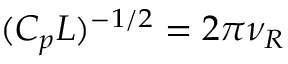<formula> <loc_0><loc_0><loc_500><loc_500>( C _ { p } L ) ^ { - 1 / 2 } = 2 \pi \nu _ { R }</formula> 